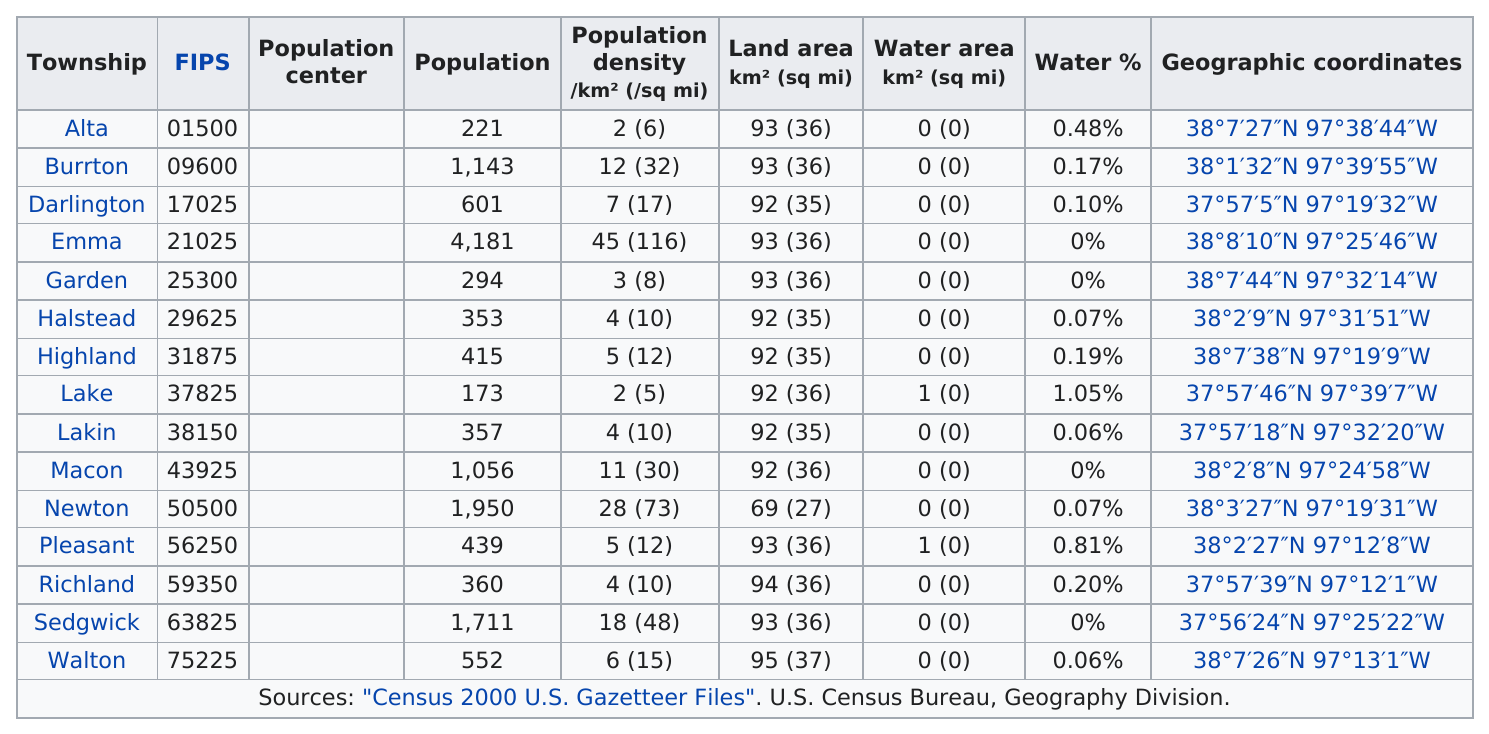Mention a couple of crucial points in this snapshot. The township with the highest population is Emma. There are townships that have the same water area as Lake Township. One example is Pleasant Township. What city has the largest population? It is Emma. It is estimated that approximately 5 cities have a land area of approximately 92 square kilometers. Compared to Darlington, which city has the next largest water percentage? The answer is Burrton. 